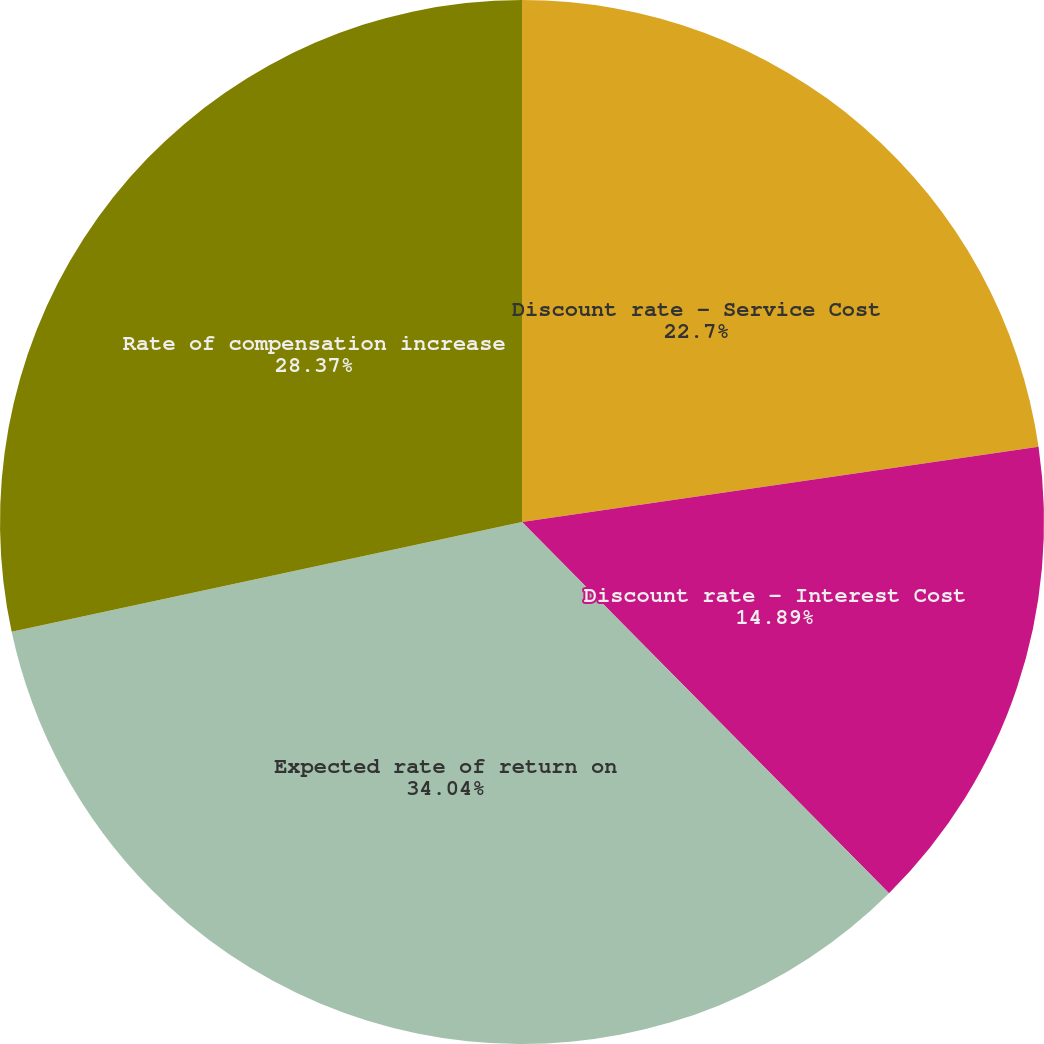<chart> <loc_0><loc_0><loc_500><loc_500><pie_chart><fcel>Discount rate - Service Cost<fcel>Discount rate - Interest Cost<fcel>Expected rate of return on<fcel>Rate of compensation increase<nl><fcel>22.7%<fcel>14.89%<fcel>34.04%<fcel>28.37%<nl></chart> 